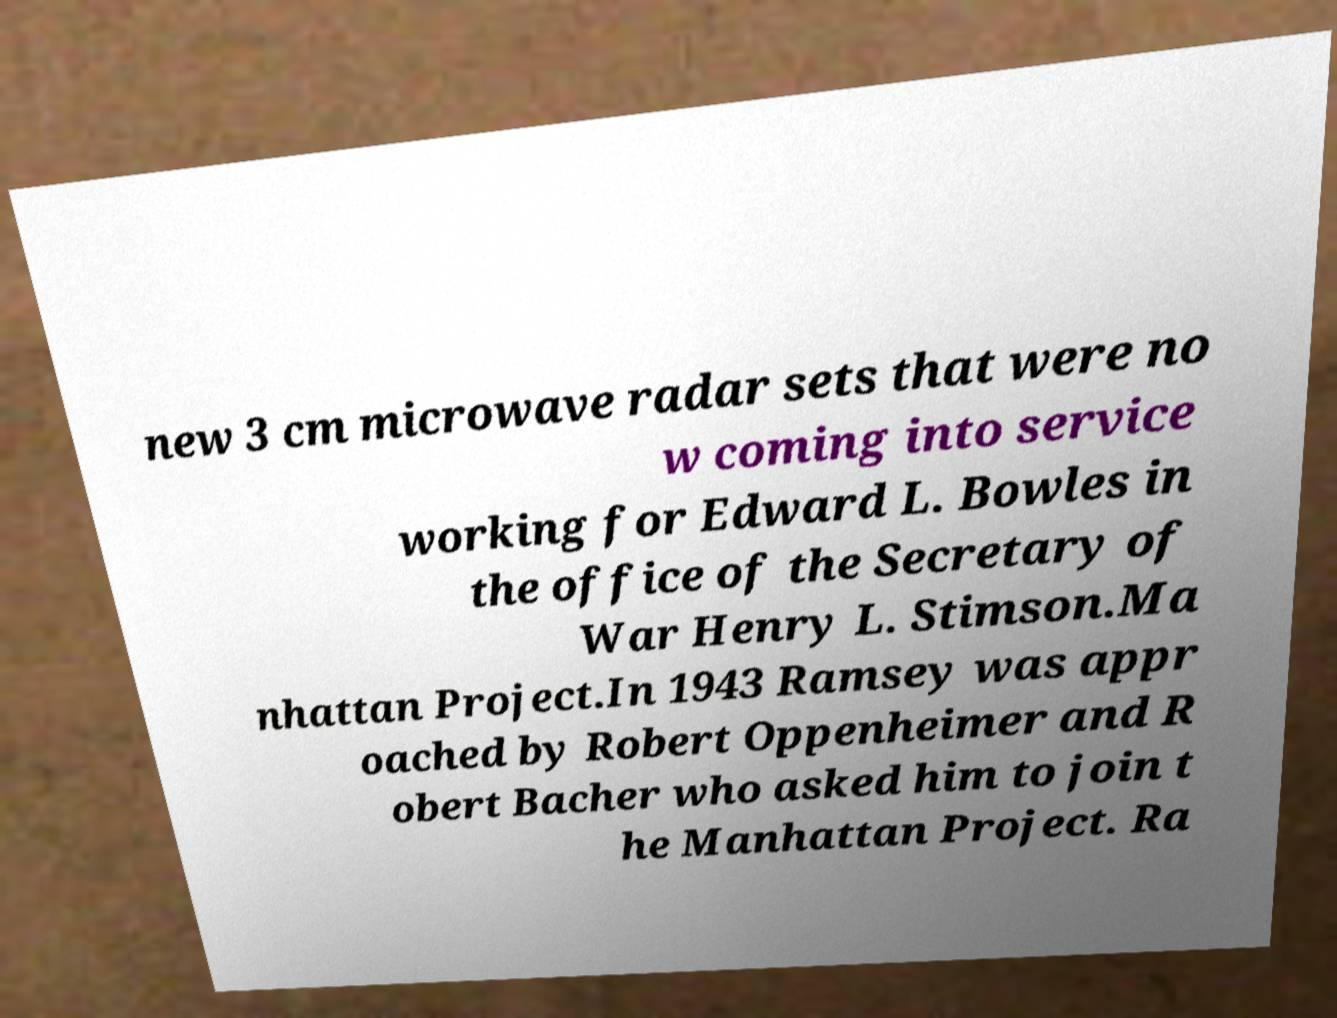Can you accurately transcribe the text from the provided image for me? new 3 cm microwave radar sets that were no w coming into service working for Edward L. Bowles in the office of the Secretary of War Henry L. Stimson.Ma nhattan Project.In 1943 Ramsey was appr oached by Robert Oppenheimer and R obert Bacher who asked him to join t he Manhattan Project. Ra 